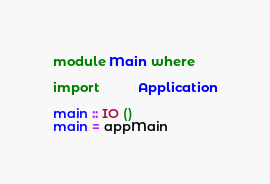<code> <loc_0><loc_0><loc_500><loc_500><_Haskell_>module Main where

import           Application

main :: IO ()
main = appMain
</code> 